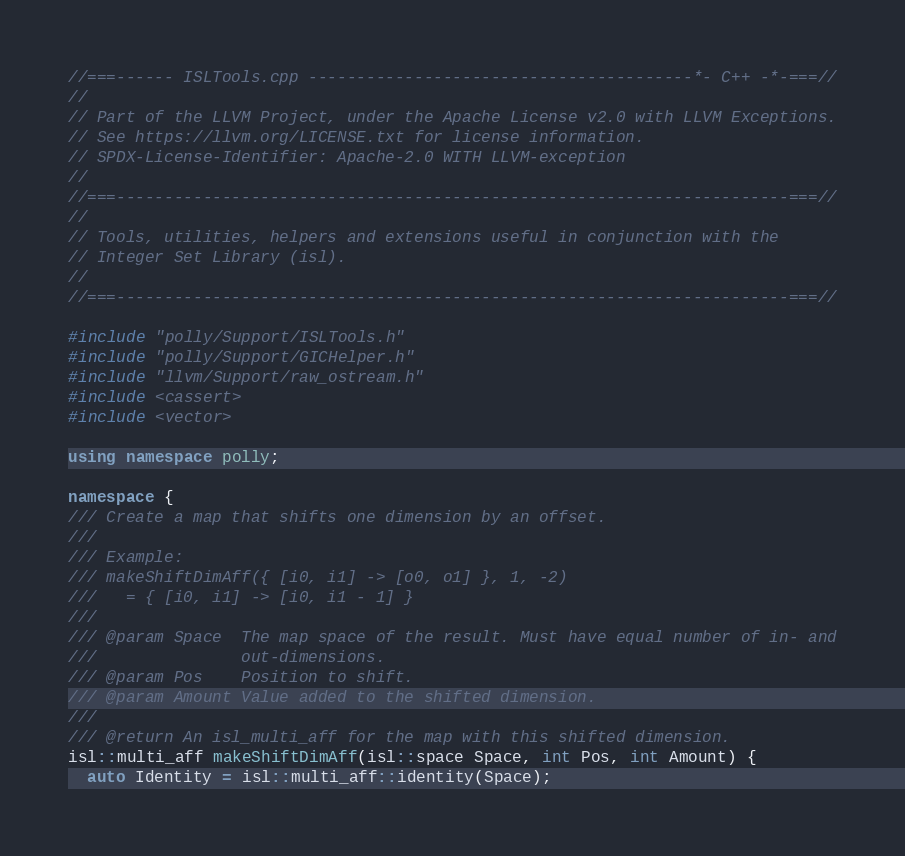<code> <loc_0><loc_0><loc_500><loc_500><_C++_>//===------ ISLTools.cpp ----------------------------------------*- C++ -*-===//
//
// Part of the LLVM Project, under the Apache License v2.0 with LLVM Exceptions.
// See https://llvm.org/LICENSE.txt for license information.
// SPDX-License-Identifier: Apache-2.0 WITH LLVM-exception
//
//===----------------------------------------------------------------------===//
//
// Tools, utilities, helpers and extensions useful in conjunction with the
// Integer Set Library (isl).
//
//===----------------------------------------------------------------------===//

#include "polly/Support/ISLTools.h"
#include "polly/Support/GICHelper.h"
#include "llvm/Support/raw_ostream.h"
#include <cassert>
#include <vector>

using namespace polly;

namespace {
/// Create a map that shifts one dimension by an offset.
///
/// Example:
/// makeShiftDimAff({ [i0, i1] -> [o0, o1] }, 1, -2)
///   = { [i0, i1] -> [i0, i1 - 1] }
///
/// @param Space  The map space of the result. Must have equal number of in- and
///               out-dimensions.
/// @param Pos    Position to shift.
/// @param Amount Value added to the shifted dimension.
///
/// @return An isl_multi_aff for the map with this shifted dimension.
isl::multi_aff makeShiftDimAff(isl::space Space, int Pos, int Amount) {
  auto Identity = isl::multi_aff::identity(Space);</code> 